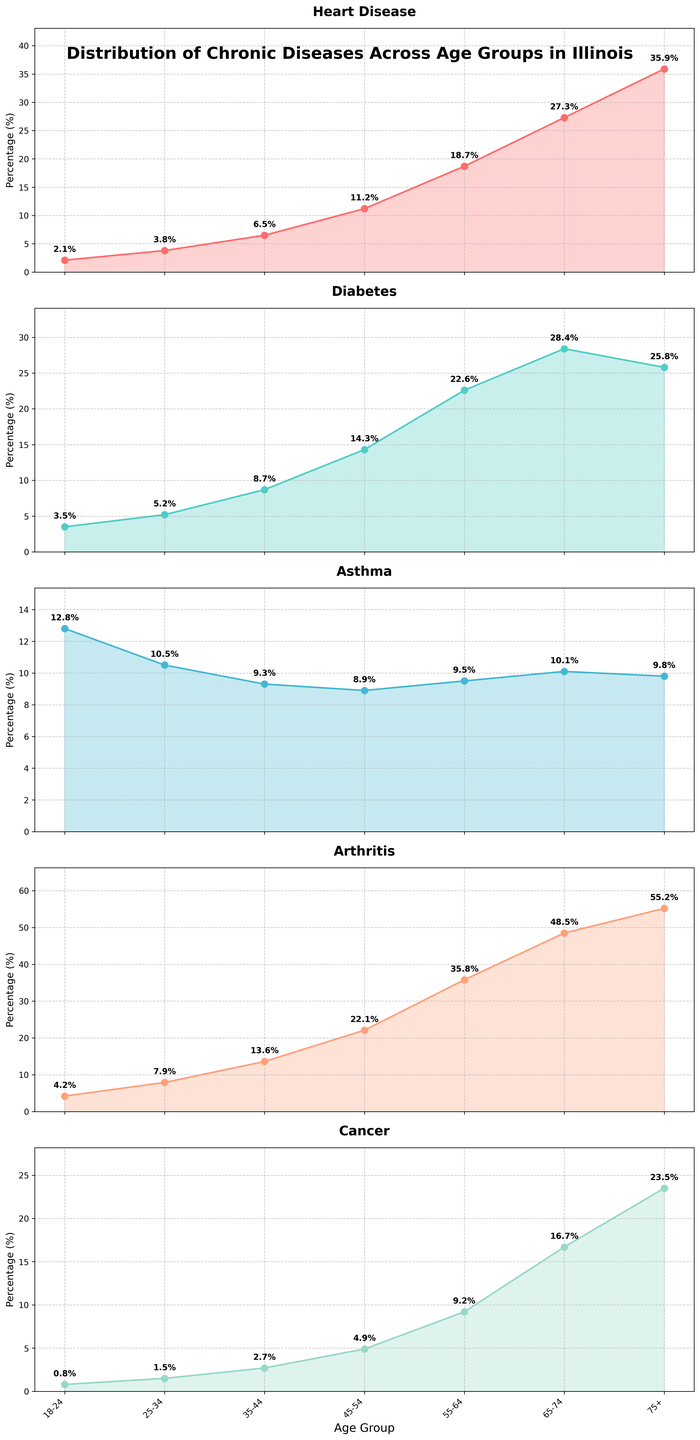What age group has the highest percentage of heart disease? The subplot for 'Heart Disease' shows a line representing the percentage of heart disease across different age groups. By looking at the height of the line, the age group 75+ has the highest value.
Answer: 75+ Which disease has the highest percentage in the 55-64 age group? By examining the data points and annotations in each subplot for the 55-64 age group, the bar representing arthritis has the highest percentage.
Answer: Arthritis What is the difference in the percentage of diabetes between the age groups 65-74 and 75+? The percentage of diabetes for the age group 65-74 is 28.4%, and for 75+ it is 25.8%. The difference is calculated as 28.4 - 25.8.
Answer: 2.6% Which age group has the lowest percentage of asthma? The subplot for 'Asthma' shows that the lowest percentage is annotated for the age group 45-54.
Answer: 45-54 What is the average percentage of cancer across all age groups? To find the average, sum the percentages of cancer across all age groups (0.8 + 1.5 + 2.7 + 4.9 + 9.2 + 16.7 + 23.5) and divide by the number of age groups (7). (0.8 + 1.5 + 2.7 + 4.9 + 9.2 + 16.7 + 23.5) / 7 = 8.61%.
Answer: 8.61% Compare the trend of heart disease and arthritis as age increases: which one shows a steeper increase? By visually inspecting the slope of the lines in the 'Heart Disease' and 'Arthritis' subplots, arthritis shows a steeper increase as age increases.
Answer: Arthritis How does the percentage of diabetes in the 25-34 age group compare to the 18-24 age group? The subplot for 'Diabetes' indicates that the percentage for the 25-34 age group is higher than that for the 18-24 age group. The values are 5.2% and 3.5%, respectively.
Answer: 25-34 is higher What is the sum of the percentages of heart disease and cancer for the 75+ age group? Adding the percentages for heart disease (35.9%) and cancer (23.5%) for the 75+ age group: 35.9 + 23.5.
Answer: 59.4% Which disease shows the least variation across different age groups? By looking at the smoothness and flatness of the lines in the subplots, the asthma line has the least variation across different age groups.
Answer: Asthma What is the trend in the percentage of asthma from age group 18-24 to 35-44? Observing the subplot for asthma, the percentage decreases from the age group 18-24 to the age group 35-44. It starts at 12.8%, then goes to 10.5%, and then to 9.3%.
Answer: Decreasing 